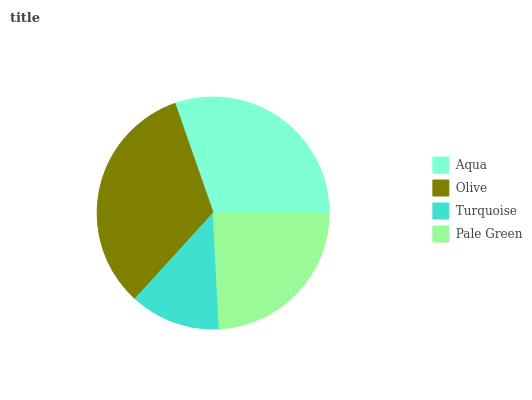Is Turquoise the minimum?
Answer yes or no. Yes. Is Olive the maximum?
Answer yes or no. Yes. Is Olive the minimum?
Answer yes or no. No. Is Turquoise the maximum?
Answer yes or no. No. Is Olive greater than Turquoise?
Answer yes or no. Yes. Is Turquoise less than Olive?
Answer yes or no. Yes. Is Turquoise greater than Olive?
Answer yes or no. No. Is Olive less than Turquoise?
Answer yes or no. No. Is Aqua the high median?
Answer yes or no. Yes. Is Pale Green the low median?
Answer yes or no. Yes. Is Turquoise the high median?
Answer yes or no. No. Is Aqua the low median?
Answer yes or no. No. 